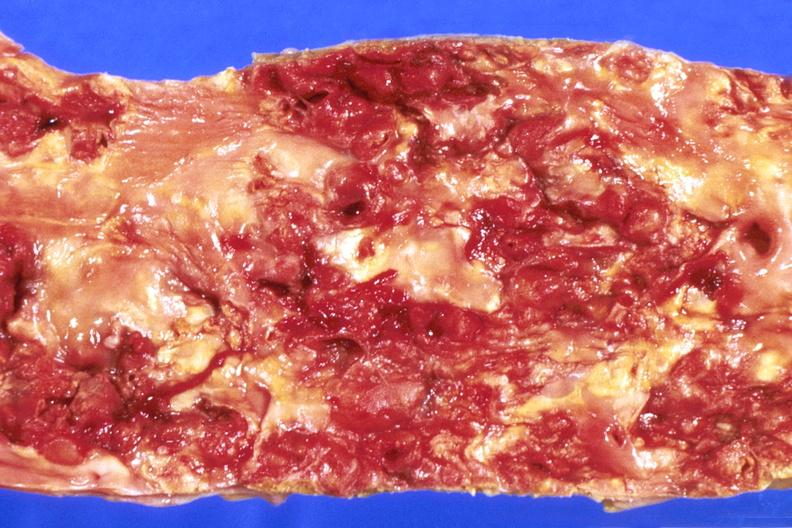what does this image show?
Answer the question using a single word or phrase. Abdominal aorta 